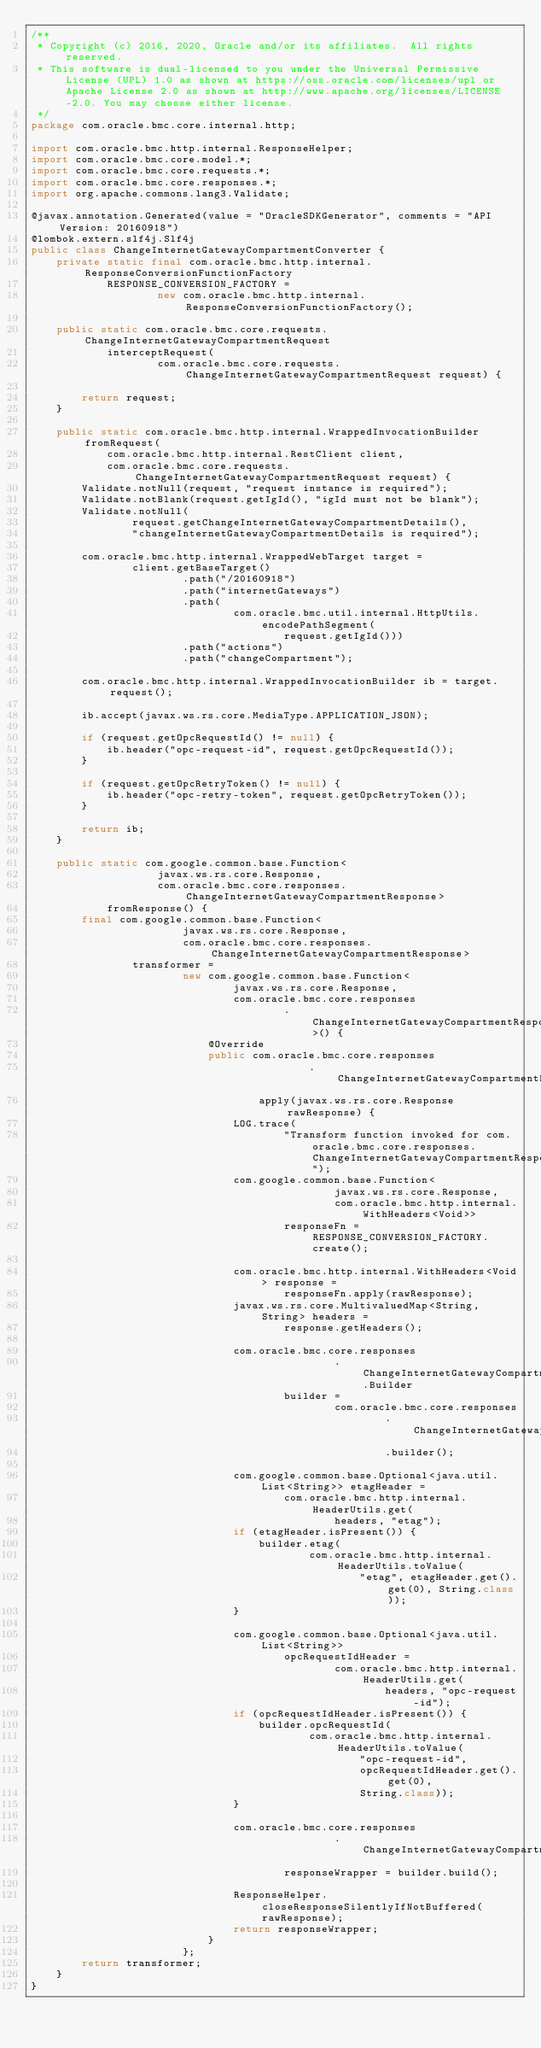Convert code to text. <code><loc_0><loc_0><loc_500><loc_500><_Java_>/**
 * Copyright (c) 2016, 2020, Oracle and/or its affiliates.  All rights reserved.
 * This software is dual-licensed to you under the Universal Permissive License (UPL) 1.0 as shown at https://oss.oracle.com/licenses/upl or Apache License 2.0 as shown at http://www.apache.org/licenses/LICENSE-2.0. You may choose either license.
 */
package com.oracle.bmc.core.internal.http;

import com.oracle.bmc.http.internal.ResponseHelper;
import com.oracle.bmc.core.model.*;
import com.oracle.bmc.core.requests.*;
import com.oracle.bmc.core.responses.*;
import org.apache.commons.lang3.Validate;

@javax.annotation.Generated(value = "OracleSDKGenerator", comments = "API Version: 20160918")
@lombok.extern.slf4j.Slf4j
public class ChangeInternetGatewayCompartmentConverter {
    private static final com.oracle.bmc.http.internal.ResponseConversionFunctionFactory
            RESPONSE_CONVERSION_FACTORY =
                    new com.oracle.bmc.http.internal.ResponseConversionFunctionFactory();

    public static com.oracle.bmc.core.requests.ChangeInternetGatewayCompartmentRequest
            interceptRequest(
                    com.oracle.bmc.core.requests.ChangeInternetGatewayCompartmentRequest request) {

        return request;
    }

    public static com.oracle.bmc.http.internal.WrappedInvocationBuilder fromRequest(
            com.oracle.bmc.http.internal.RestClient client,
            com.oracle.bmc.core.requests.ChangeInternetGatewayCompartmentRequest request) {
        Validate.notNull(request, "request instance is required");
        Validate.notBlank(request.getIgId(), "igId must not be blank");
        Validate.notNull(
                request.getChangeInternetGatewayCompartmentDetails(),
                "changeInternetGatewayCompartmentDetails is required");

        com.oracle.bmc.http.internal.WrappedWebTarget target =
                client.getBaseTarget()
                        .path("/20160918")
                        .path("internetGateways")
                        .path(
                                com.oracle.bmc.util.internal.HttpUtils.encodePathSegment(
                                        request.getIgId()))
                        .path("actions")
                        .path("changeCompartment");

        com.oracle.bmc.http.internal.WrappedInvocationBuilder ib = target.request();

        ib.accept(javax.ws.rs.core.MediaType.APPLICATION_JSON);

        if (request.getOpcRequestId() != null) {
            ib.header("opc-request-id", request.getOpcRequestId());
        }

        if (request.getOpcRetryToken() != null) {
            ib.header("opc-retry-token", request.getOpcRetryToken());
        }

        return ib;
    }

    public static com.google.common.base.Function<
                    javax.ws.rs.core.Response,
                    com.oracle.bmc.core.responses.ChangeInternetGatewayCompartmentResponse>
            fromResponse() {
        final com.google.common.base.Function<
                        javax.ws.rs.core.Response,
                        com.oracle.bmc.core.responses.ChangeInternetGatewayCompartmentResponse>
                transformer =
                        new com.google.common.base.Function<
                                javax.ws.rs.core.Response,
                                com.oracle.bmc.core.responses
                                        .ChangeInternetGatewayCompartmentResponse>() {
                            @Override
                            public com.oracle.bmc.core.responses
                                            .ChangeInternetGatewayCompartmentResponse
                                    apply(javax.ws.rs.core.Response rawResponse) {
                                LOG.trace(
                                        "Transform function invoked for com.oracle.bmc.core.responses.ChangeInternetGatewayCompartmentResponse");
                                com.google.common.base.Function<
                                                javax.ws.rs.core.Response,
                                                com.oracle.bmc.http.internal.WithHeaders<Void>>
                                        responseFn = RESPONSE_CONVERSION_FACTORY.create();

                                com.oracle.bmc.http.internal.WithHeaders<Void> response =
                                        responseFn.apply(rawResponse);
                                javax.ws.rs.core.MultivaluedMap<String, String> headers =
                                        response.getHeaders();

                                com.oracle.bmc.core.responses
                                                .ChangeInternetGatewayCompartmentResponse.Builder
                                        builder =
                                                com.oracle.bmc.core.responses
                                                        .ChangeInternetGatewayCompartmentResponse
                                                        .builder();

                                com.google.common.base.Optional<java.util.List<String>> etagHeader =
                                        com.oracle.bmc.http.internal.HeaderUtils.get(
                                                headers, "etag");
                                if (etagHeader.isPresent()) {
                                    builder.etag(
                                            com.oracle.bmc.http.internal.HeaderUtils.toValue(
                                                    "etag", etagHeader.get().get(0), String.class));
                                }

                                com.google.common.base.Optional<java.util.List<String>>
                                        opcRequestIdHeader =
                                                com.oracle.bmc.http.internal.HeaderUtils.get(
                                                        headers, "opc-request-id");
                                if (opcRequestIdHeader.isPresent()) {
                                    builder.opcRequestId(
                                            com.oracle.bmc.http.internal.HeaderUtils.toValue(
                                                    "opc-request-id",
                                                    opcRequestIdHeader.get().get(0),
                                                    String.class));
                                }

                                com.oracle.bmc.core.responses
                                                .ChangeInternetGatewayCompartmentResponse
                                        responseWrapper = builder.build();

                                ResponseHelper.closeResponseSilentlyIfNotBuffered(rawResponse);
                                return responseWrapper;
                            }
                        };
        return transformer;
    }
}
</code> 